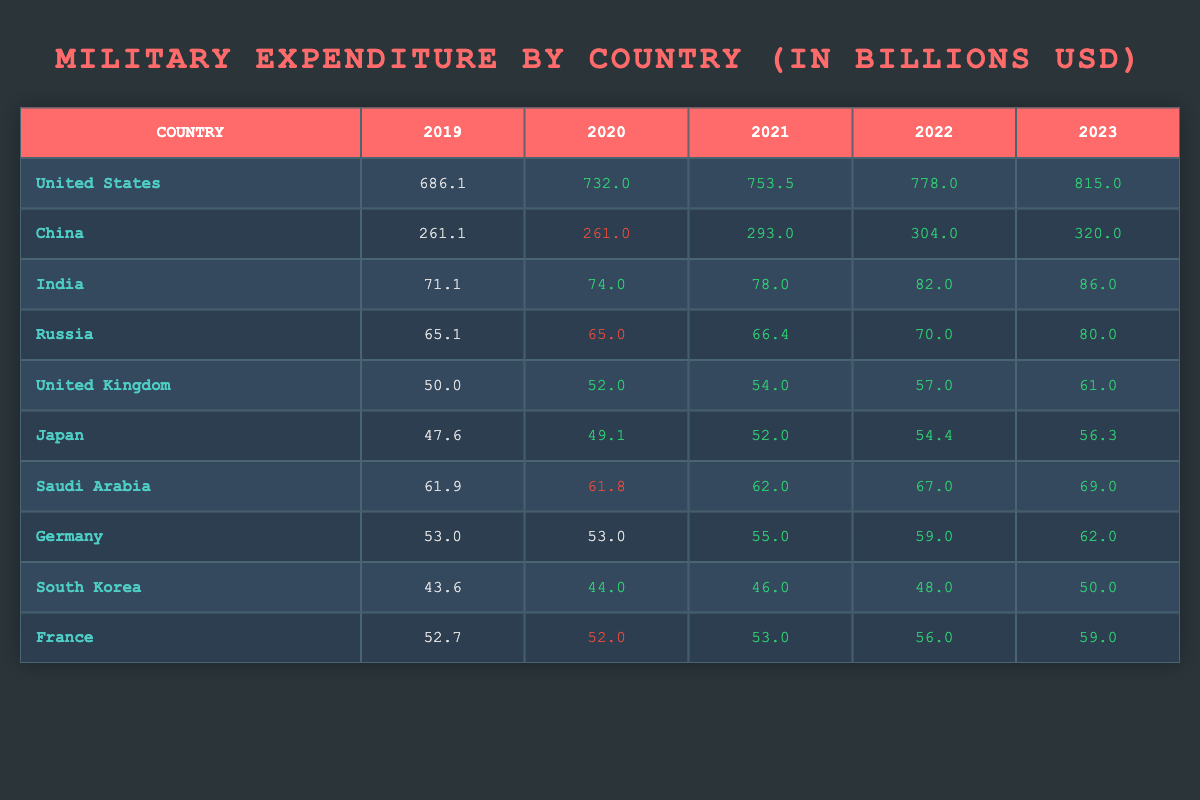What was the military expenditure of the United States in 2022? The table shows that the military expenditure for the United States in 2022 was 778.0 billion USD.
Answer: 778.0 billion USD Which country had the highest military expenditure in 2023? According to the table, the United States had the highest military expenditure in 2023, which was 815.0 billion USD.
Answer: United States Did Saudi Arabia's military expenditure increase from 2019 to 2023? By comparing the values, Saudi Arabia's expenditure in 2019 was 61.9 billion USD and in 2023 it was 69.0 billion USD. Therefore, it increased over this period.
Answer: Yes What is the total military expenditure of China from 2019 to 2023? To find the total, add the expenditures: 261.1 + 261.0 + 293.0 + 304.0 + 320.0 = 1399.1 billion USD.
Answer: 1399.1 billion USD Which country had the lowest military expenditure in 2021? The table indicates that Japan had the lowest military expenditure in 2021 with 52.0 billion USD, compared to other countries listed.
Answer: Japan What was the average military expenditure for India from 2019 to 2023? The expenditures for India are: 71.1, 74.0, 78.0, 82.0, and 86.0. The total is 391.1 billion USD, divided by 5 gives an average expenditure of 78.22 billion USD.
Answer: 78.22 billion USD Did any country have a decrease in military expenditure from 2020 to 2021? Looking at the data, China and Russia both decreased their expenditures from 2020 to 2021, showing a decrease of 0.1 billion USD for China and 0.2 billion USD for Russia.
Answer: Yes What was the percentage increase in military expenditure of the United Kingdom from 2019 to 2023? The expenditure increased from 50.0 billion USD in 2019 to 61.0 billion USD in 2023. The increase is 11.0 billion USD. To find the percentage increase: (11.0/50.0) * 100 = 22%.
Answer: 22% Which year saw the highest military expenditure for Russia? According to the table, Russia's highest military expenditure was in 2023 with 80.0 billion USD.
Answer: 2023 Was India's military expenditure greater than Japan's in 2022? India's military expenditure in 2022 was 82.0 billion USD, while Japan's was 54.4 billion USD, which confirms that India's expenditure was greater.
Answer: Yes 